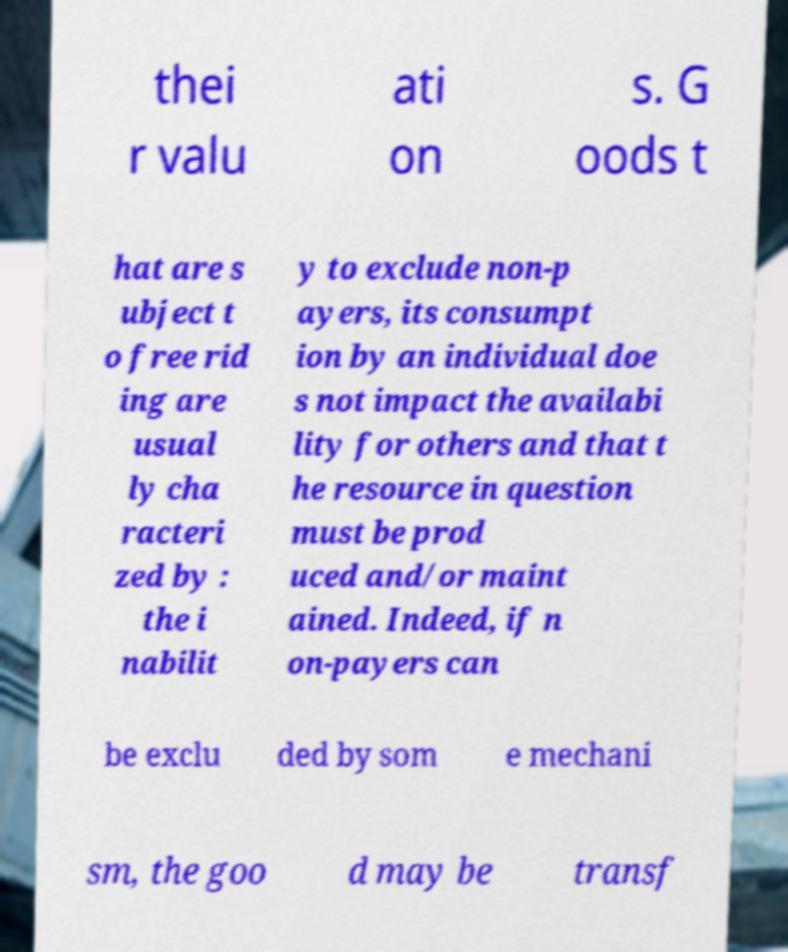There's text embedded in this image that I need extracted. Can you transcribe it verbatim? thei r valu ati on s. G oods t hat are s ubject t o free rid ing are usual ly cha racteri zed by : the i nabilit y to exclude non-p ayers, its consumpt ion by an individual doe s not impact the availabi lity for others and that t he resource in question must be prod uced and/or maint ained. Indeed, if n on-payers can be exclu ded by som e mechani sm, the goo d may be transf 